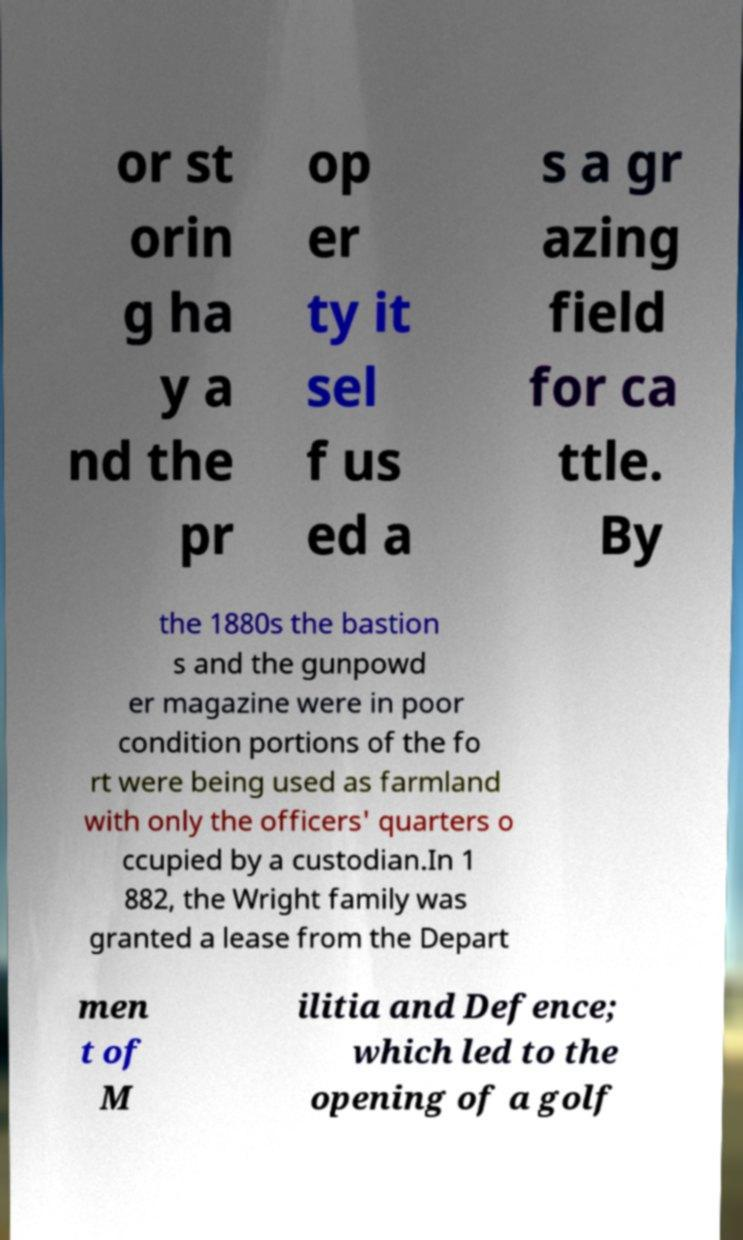There's text embedded in this image that I need extracted. Can you transcribe it verbatim? or st orin g ha y a nd the pr op er ty it sel f us ed a s a gr azing field for ca ttle. By the 1880s the bastion s and the gunpowd er magazine were in poor condition portions of the fo rt were being used as farmland with only the officers' quarters o ccupied by a custodian.In 1 882, the Wright family was granted a lease from the Depart men t of M ilitia and Defence; which led to the opening of a golf 